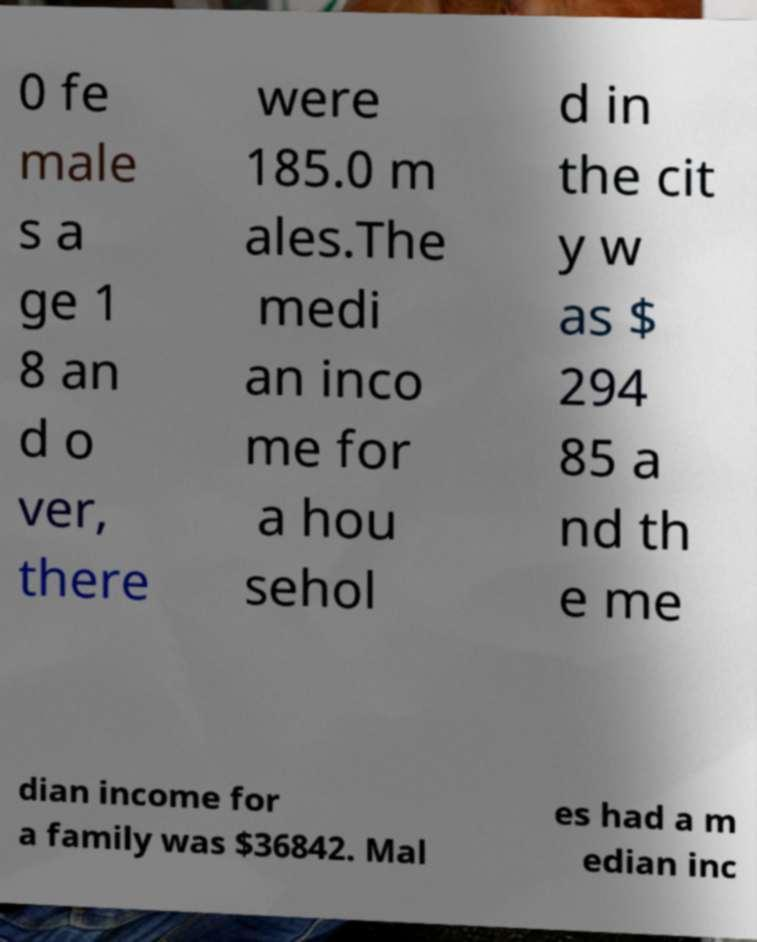There's text embedded in this image that I need extracted. Can you transcribe it verbatim? 0 fe male s a ge 1 8 an d o ver, there were 185.0 m ales.The medi an inco me for a hou sehol d in the cit y w as $ 294 85 a nd th e me dian income for a family was $36842. Mal es had a m edian inc 